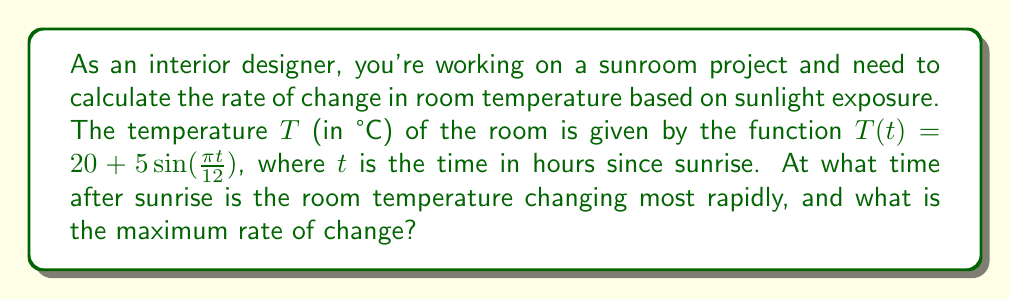Give your solution to this math problem. To solve this problem, we need to follow these steps:

1) First, we need to find the derivative of the temperature function $T(t)$. This will give us the rate of change of temperature with respect to time.

   $T(t) = 20 + 5\sin(\frac{\pi t}{12})$
   $T'(t) = 5 \cdot \frac{\pi}{12} \cos(\frac{\pi t}{12})$
   $T'(t) = \frac{5\pi}{12} \cos(\frac{\pi t}{12})$

2) The rate of change is maximum when $|T'(t)|$ is at its maximum. The cosine function has a maximum value of 1 and a minimum value of -1.

3) $|T'(t)|$ is maximum when $\cos(\frac{\pi t}{12}) = \pm 1$

4) This occurs when $\frac{\pi t}{12} = 0, \pi, 2\pi, ...$

5) Solving for $t$:
   $t = 0, 12, 24, ...$

6) The first positive time is at $t = 0$ hours after sunrise.

7) The maximum rate of change is:
   $|T'(0)| = |\frac{5\pi}{12}| \approx 1.31$ °C/hour
Answer: The temperature changes most rapidly at sunrise ($t = 0$ hours) and every 12 hours thereafter, with a maximum rate of change of $\frac{5\pi}{12}$ °C/hour ($\approx 1.31$ °C/hour). 